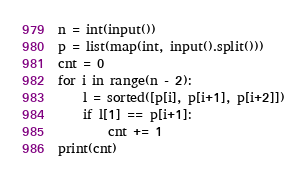<code> <loc_0><loc_0><loc_500><loc_500><_Python_>n = int(input())
p = list(map(int, input().split()))
cnt = 0
for i in range(n - 2):
    l = sorted([p[i], p[i+1], p[i+2]])
    if l[1] == p[i+1]:
        cnt += 1
print(cnt)
</code> 